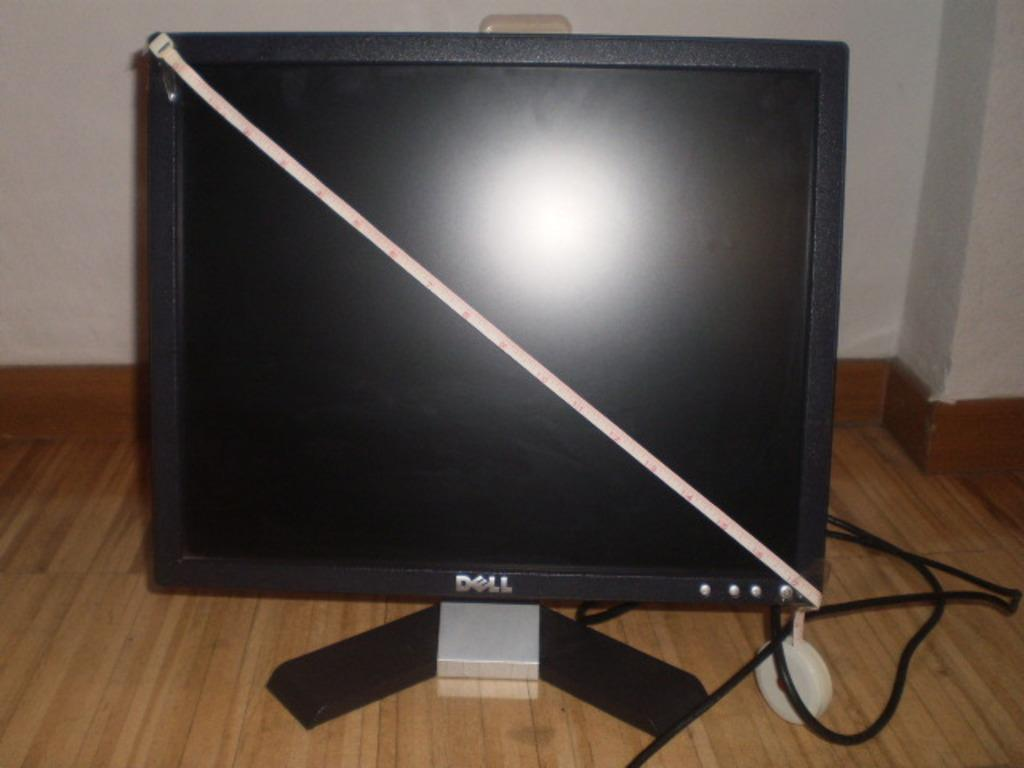<image>
Summarize the visual content of the image. The flat screen Dell computer is being measured for its actual size. 